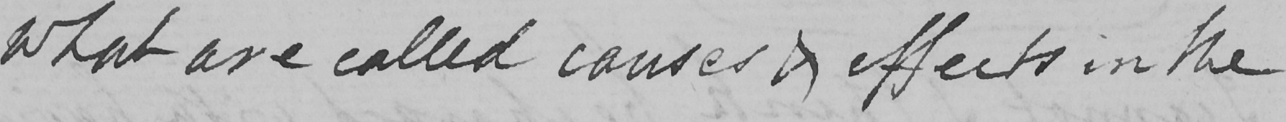Please transcribe the handwritten text in this image. what are called causes & effects in the 